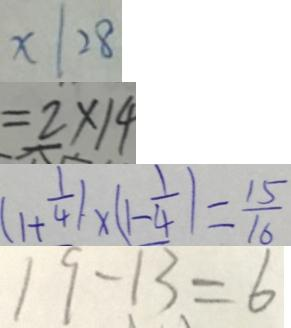Convert formula to latex. <formula><loc_0><loc_0><loc_500><loc_500>x \vert 2 8 
 = 2 \times 1 4 
 ( 1 + \frac { 1 } { 4 } ) \times ( 1 - \frac { 1 } { 4 } ) = \frac { 1 5 } { 1 6 } 
 1 9 - 1 3 = 6</formula> 